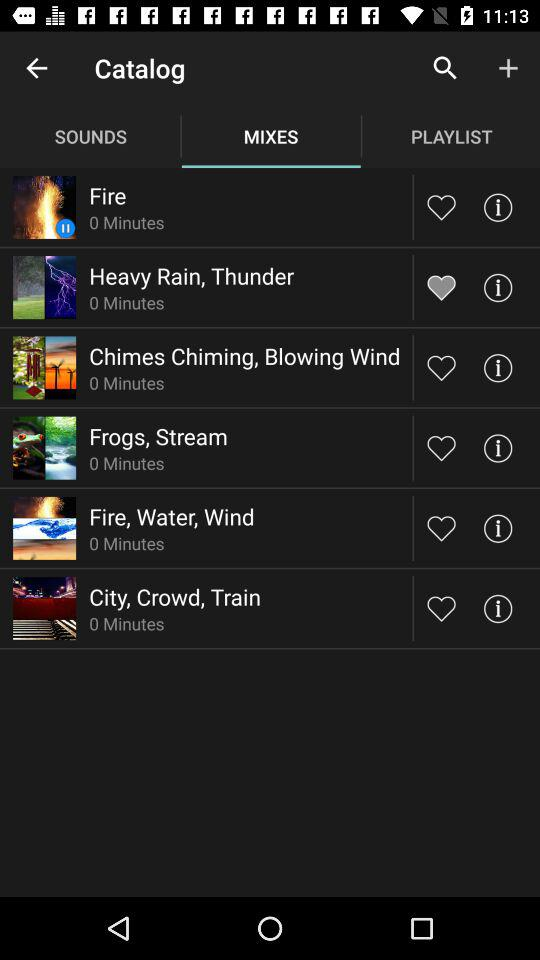What is the duration of the "Fire" sound? The duration of the "Fire" sound is 0 minutes. 